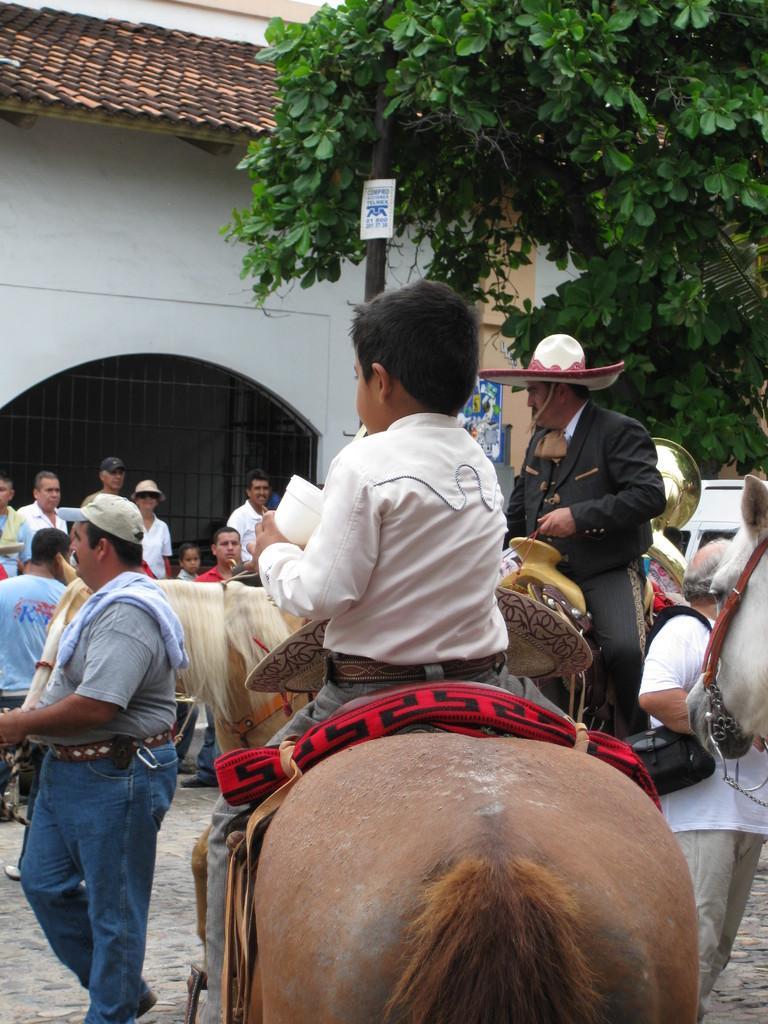Please provide a concise description of this image. The image is taken on a street. There is a boy sitting on a horse. On the left there is a man walking. In the background there are people, building and a tree. 